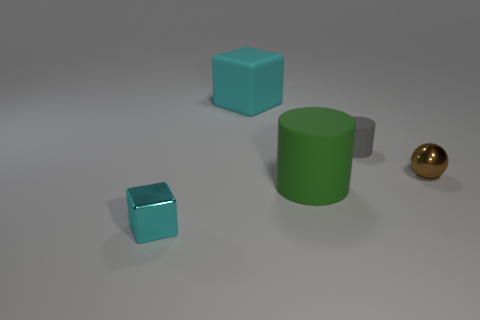Add 5 gray objects. How many objects exist? 10 Subtract all cylinders. How many objects are left? 3 Subtract all gray cylinders. How many cylinders are left? 1 Subtract 1 spheres. How many spheres are left? 0 Subtract all small green objects. Subtract all small gray rubber cylinders. How many objects are left? 4 Add 1 gray rubber things. How many gray rubber things are left? 2 Add 4 matte objects. How many matte objects exist? 7 Subtract 0 purple blocks. How many objects are left? 5 Subtract all red balls. Subtract all yellow cubes. How many balls are left? 1 